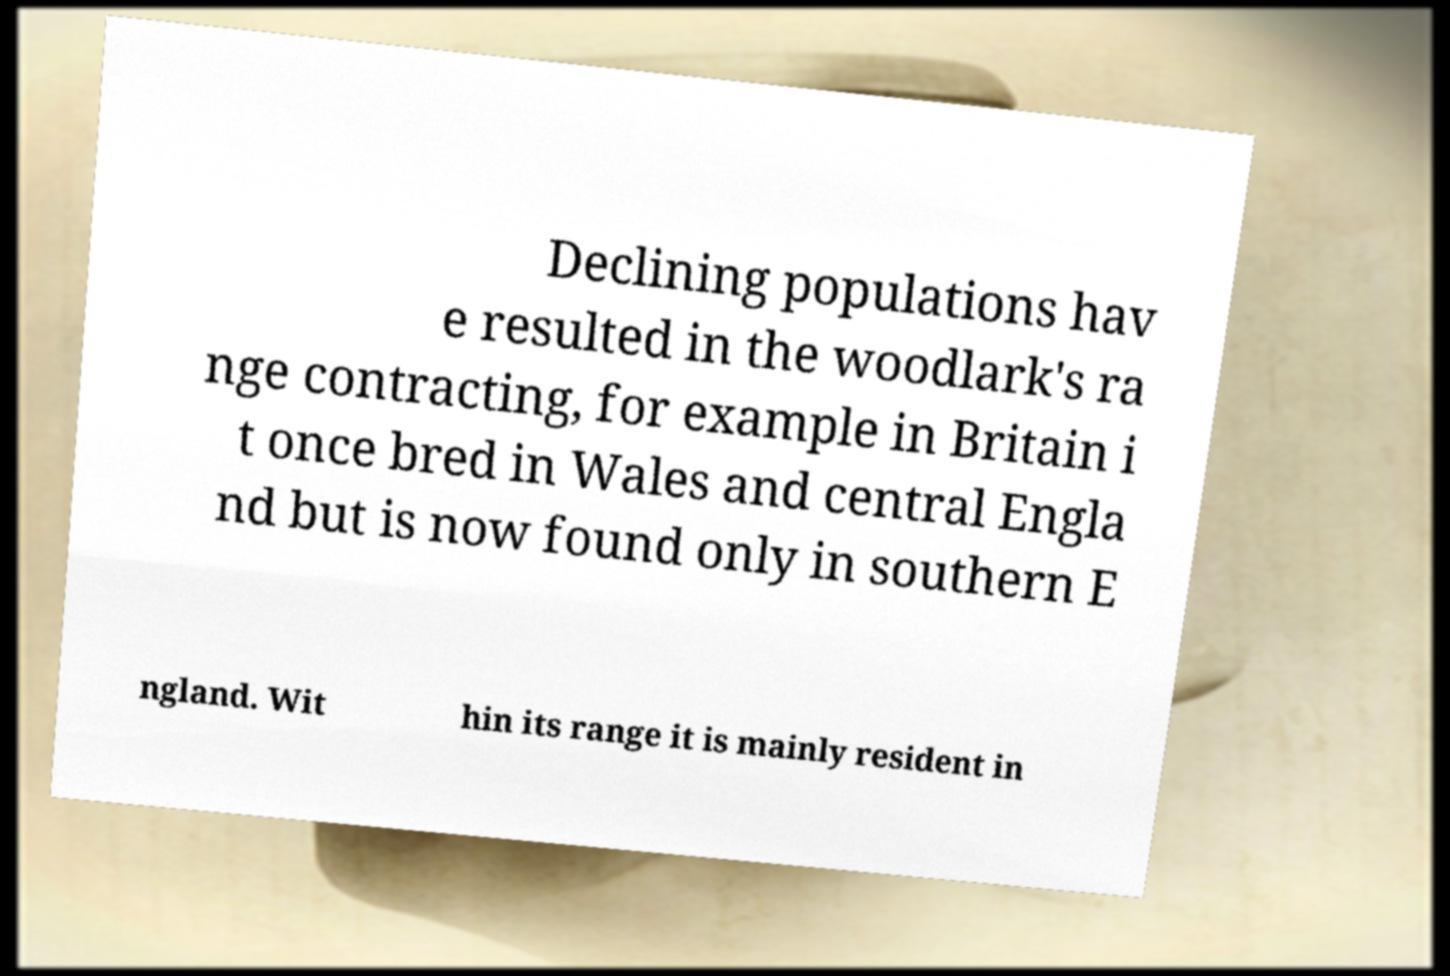Please identify and transcribe the text found in this image. Declining populations hav e resulted in the woodlark's ra nge contracting, for example in Britain i t once bred in Wales and central Engla nd but is now found only in southern E ngland. Wit hin its range it is mainly resident in 